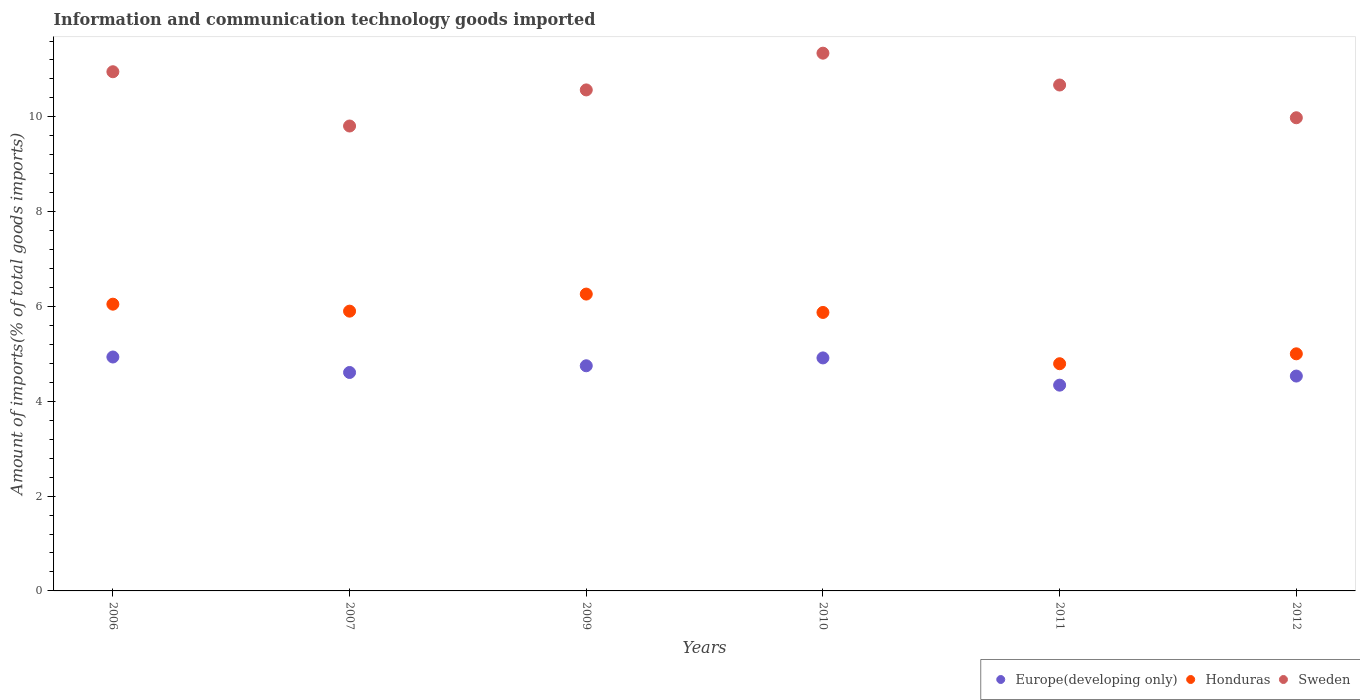How many different coloured dotlines are there?
Your answer should be compact. 3. Is the number of dotlines equal to the number of legend labels?
Your answer should be compact. Yes. What is the amount of goods imported in Sweden in 2009?
Provide a short and direct response. 10.57. Across all years, what is the maximum amount of goods imported in Honduras?
Your answer should be compact. 6.26. Across all years, what is the minimum amount of goods imported in Sweden?
Keep it short and to the point. 9.81. In which year was the amount of goods imported in Honduras minimum?
Offer a terse response. 2011. What is the total amount of goods imported in Sweden in the graph?
Your answer should be compact. 63.33. What is the difference between the amount of goods imported in Europe(developing only) in 2006 and that in 2012?
Your answer should be compact. 0.4. What is the difference between the amount of goods imported in Sweden in 2006 and the amount of goods imported in Honduras in 2010?
Provide a succinct answer. 5.08. What is the average amount of goods imported in Sweden per year?
Ensure brevity in your answer.  10.55. In the year 2006, what is the difference between the amount of goods imported in Honduras and amount of goods imported in Sweden?
Ensure brevity in your answer.  -4.9. In how many years, is the amount of goods imported in Europe(developing only) greater than 6.4 %?
Provide a short and direct response. 0. What is the ratio of the amount of goods imported in Sweden in 2007 to that in 2012?
Provide a short and direct response. 0.98. Is the amount of goods imported in Europe(developing only) in 2009 less than that in 2010?
Keep it short and to the point. Yes. Is the difference between the amount of goods imported in Honduras in 2006 and 2011 greater than the difference between the amount of goods imported in Sweden in 2006 and 2011?
Your answer should be very brief. Yes. What is the difference between the highest and the second highest amount of goods imported in Honduras?
Your answer should be very brief. 0.21. What is the difference between the highest and the lowest amount of goods imported in Sweden?
Offer a very short reply. 1.54. In how many years, is the amount of goods imported in Europe(developing only) greater than the average amount of goods imported in Europe(developing only) taken over all years?
Provide a succinct answer. 3. Is the sum of the amount of goods imported in Sweden in 2006 and 2009 greater than the maximum amount of goods imported in Europe(developing only) across all years?
Your answer should be compact. Yes. Is it the case that in every year, the sum of the amount of goods imported in Honduras and amount of goods imported in Sweden  is greater than the amount of goods imported in Europe(developing only)?
Offer a very short reply. Yes. Is the amount of goods imported in Europe(developing only) strictly less than the amount of goods imported in Honduras over the years?
Provide a short and direct response. Yes. How many dotlines are there?
Your response must be concise. 3. How many years are there in the graph?
Offer a very short reply. 6. Are the values on the major ticks of Y-axis written in scientific E-notation?
Keep it short and to the point. No. Where does the legend appear in the graph?
Your response must be concise. Bottom right. How are the legend labels stacked?
Keep it short and to the point. Horizontal. What is the title of the graph?
Make the answer very short. Information and communication technology goods imported. What is the label or title of the Y-axis?
Your response must be concise. Amount of imports(% of total goods imports). What is the Amount of imports(% of total goods imports) of Europe(developing only) in 2006?
Your answer should be compact. 4.93. What is the Amount of imports(% of total goods imports) in Honduras in 2006?
Ensure brevity in your answer.  6.05. What is the Amount of imports(% of total goods imports) of Sweden in 2006?
Ensure brevity in your answer.  10.95. What is the Amount of imports(% of total goods imports) of Europe(developing only) in 2007?
Give a very brief answer. 4.61. What is the Amount of imports(% of total goods imports) in Honduras in 2007?
Provide a succinct answer. 5.9. What is the Amount of imports(% of total goods imports) in Sweden in 2007?
Give a very brief answer. 9.81. What is the Amount of imports(% of total goods imports) in Europe(developing only) in 2009?
Your response must be concise. 4.75. What is the Amount of imports(% of total goods imports) in Honduras in 2009?
Your answer should be compact. 6.26. What is the Amount of imports(% of total goods imports) of Sweden in 2009?
Provide a succinct answer. 10.57. What is the Amount of imports(% of total goods imports) of Europe(developing only) in 2010?
Offer a terse response. 4.92. What is the Amount of imports(% of total goods imports) of Honduras in 2010?
Your answer should be very brief. 5.87. What is the Amount of imports(% of total goods imports) of Sweden in 2010?
Offer a terse response. 11.34. What is the Amount of imports(% of total goods imports) of Europe(developing only) in 2011?
Provide a succinct answer. 4.34. What is the Amount of imports(% of total goods imports) of Honduras in 2011?
Ensure brevity in your answer.  4.79. What is the Amount of imports(% of total goods imports) of Sweden in 2011?
Give a very brief answer. 10.67. What is the Amount of imports(% of total goods imports) of Europe(developing only) in 2012?
Your answer should be very brief. 4.53. What is the Amount of imports(% of total goods imports) in Honduras in 2012?
Offer a terse response. 5. What is the Amount of imports(% of total goods imports) in Sweden in 2012?
Your answer should be compact. 9.98. Across all years, what is the maximum Amount of imports(% of total goods imports) in Europe(developing only)?
Your answer should be compact. 4.93. Across all years, what is the maximum Amount of imports(% of total goods imports) in Honduras?
Your answer should be compact. 6.26. Across all years, what is the maximum Amount of imports(% of total goods imports) of Sweden?
Make the answer very short. 11.34. Across all years, what is the minimum Amount of imports(% of total goods imports) in Europe(developing only)?
Your answer should be compact. 4.34. Across all years, what is the minimum Amount of imports(% of total goods imports) of Honduras?
Provide a short and direct response. 4.79. Across all years, what is the minimum Amount of imports(% of total goods imports) of Sweden?
Provide a short and direct response. 9.81. What is the total Amount of imports(% of total goods imports) of Europe(developing only) in the graph?
Offer a very short reply. 28.08. What is the total Amount of imports(% of total goods imports) of Honduras in the graph?
Ensure brevity in your answer.  33.88. What is the total Amount of imports(% of total goods imports) in Sweden in the graph?
Provide a succinct answer. 63.33. What is the difference between the Amount of imports(% of total goods imports) of Europe(developing only) in 2006 and that in 2007?
Offer a terse response. 0.33. What is the difference between the Amount of imports(% of total goods imports) in Honduras in 2006 and that in 2007?
Provide a short and direct response. 0.15. What is the difference between the Amount of imports(% of total goods imports) of Sweden in 2006 and that in 2007?
Provide a short and direct response. 1.14. What is the difference between the Amount of imports(% of total goods imports) in Europe(developing only) in 2006 and that in 2009?
Your answer should be very brief. 0.19. What is the difference between the Amount of imports(% of total goods imports) of Honduras in 2006 and that in 2009?
Your response must be concise. -0.21. What is the difference between the Amount of imports(% of total goods imports) in Sweden in 2006 and that in 2009?
Give a very brief answer. 0.38. What is the difference between the Amount of imports(% of total goods imports) in Europe(developing only) in 2006 and that in 2010?
Provide a short and direct response. 0.02. What is the difference between the Amount of imports(% of total goods imports) of Honduras in 2006 and that in 2010?
Your answer should be very brief. 0.17. What is the difference between the Amount of imports(% of total goods imports) in Sweden in 2006 and that in 2010?
Offer a very short reply. -0.39. What is the difference between the Amount of imports(% of total goods imports) of Europe(developing only) in 2006 and that in 2011?
Your answer should be compact. 0.59. What is the difference between the Amount of imports(% of total goods imports) in Honduras in 2006 and that in 2011?
Give a very brief answer. 1.26. What is the difference between the Amount of imports(% of total goods imports) of Sweden in 2006 and that in 2011?
Ensure brevity in your answer.  0.28. What is the difference between the Amount of imports(% of total goods imports) of Europe(developing only) in 2006 and that in 2012?
Offer a terse response. 0.4. What is the difference between the Amount of imports(% of total goods imports) of Honduras in 2006 and that in 2012?
Your answer should be very brief. 1.05. What is the difference between the Amount of imports(% of total goods imports) of Sweden in 2006 and that in 2012?
Keep it short and to the point. 0.97. What is the difference between the Amount of imports(% of total goods imports) in Europe(developing only) in 2007 and that in 2009?
Offer a terse response. -0.14. What is the difference between the Amount of imports(% of total goods imports) of Honduras in 2007 and that in 2009?
Give a very brief answer. -0.36. What is the difference between the Amount of imports(% of total goods imports) in Sweden in 2007 and that in 2009?
Your response must be concise. -0.76. What is the difference between the Amount of imports(% of total goods imports) of Europe(developing only) in 2007 and that in 2010?
Ensure brevity in your answer.  -0.31. What is the difference between the Amount of imports(% of total goods imports) in Honduras in 2007 and that in 2010?
Offer a terse response. 0.03. What is the difference between the Amount of imports(% of total goods imports) of Sweden in 2007 and that in 2010?
Keep it short and to the point. -1.54. What is the difference between the Amount of imports(% of total goods imports) in Europe(developing only) in 2007 and that in 2011?
Provide a short and direct response. 0.27. What is the difference between the Amount of imports(% of total goods imports) of Honduras in 2007 and that in 2011?
Ensure brevity in your answer.  1.11. What is the difference between the Amount of imports(% of total goods imports) in Sweden in 2007 and that in 2011?
Offer a very short reply. -0.86. What is the difference between the Amount of imports(% of total goods imports) in Europe(developing only) in 2007 and that in 2012?
Your answer should be very brief. 0.08. What is the difference between the Amount of imports(% of total goods imports) in Honduras in 2007 and that in 2012?
Your answer should be compact. 0.9. What is the difference between the Amount of imports(% of total goods imports) in Sweden in 2007 and that in 2012?
Make the answer very short. -0.17. What is the difference between the Amount of imports(% of total goods imports) in Europe(developing only) in 2009 and that in 2010?
Keep it short and to the point. -0.17. What is the difference between the Amount of imports(% of total goods imports) of Honduras in 2009 and that in 2010?
Keep it short and to the point. 0.39. What is the difference between the Amount of imports(% of total goods imports) of Sweden in 2009 and that in 2010?
Provide a short and direct response. -0.78. What is the difference between the Amount of imports(% of total goods imports) in Europe(developing only) in 2009 and that in 2011?
Keep it short and to the point. 0.41. What is the difference between the Amount of imports(% of total goods imports) in Honduras in 2009 and that in 2011?
Keep it short and to the point. 1.47. What is the difference between the Amount of imports(% of total goods imports) of Sweden in 2009 and that in 2011?
Offer a terse response. -0.1. What is the difference between the Amount of imports(% of total goods imports) of Europe(developing only) in 2009 and that in 2012?
Make the answer very short. 0.22. What is the difference between the Amount of imports(% of total goods imports) of Honduras in 2009 and that in 2012?
Give a very brief answer. 1.26. What is the difference between the Amount of imports(% of total goods imports) in Sweden in 2009 and that in 2012?
Keep it short and to the point. 0.59. What is the difference between the Amount of imports(% of total goods imports) of Europe(developing only) in 2010 and that in 2011?
Provide a succinct answer. 0.57. What is the difference between the Amount of imports(% of total goods imports) in Honduras in 2010 and that in 2011?
Your answer should be very brief. 1.08. What is the difference between the Amount of imports(% of total goods imports) of Sweden in 2010 and that in 2011?
Provide a short and direct response. 0.67. What is the difference between the Amount of imports(% of total goods imports) of Europe(developing only) in 2010 and that in 2012?
Offer a very short reply. 0.38. What is the difference between the Amount of imports(% of total goods imports) in Honduras in 2010 and that in 2012?
Your response must be concise. 0.87. What is the difference between the Amount of imports(% of total goods imports) in Sweden in 2010 and that in 2012?
Provide a succinct answer. 1.36. What is the difference between the Amount of imports(% of total goods imports) in Europe(developing only) in 2011 and that in 2012?
Offer a very short reply. -0.19. What is the difference between the Amount of imports(% of total goods imports) of Honduras in 2011 and that in 2012?
Make the answer very short. -0.21. What is the difference between the Amount of imports(% of total goods imports) in Sweden in 2011 and that in 2012?
Give a very brief answer. 0.69. What is the difference between the Amount of imports(% of total goods imports) of Europe(developing only) in 2006 and the Amount of imports(% of total goods imports) of Honduras in 2007?
Your answer should be compact. -0.97. What is the difference between the Amount of imports(% of total goods imports) in Europe(developing only) in 2006 and the Amount of imports(% of total goods imports) in Sweden in 2007?
Keep it short and to the point. -4.87. What is the difference between the Amount of imports(% of total goods imports) of Honduras in 2006 and the Amount of imports(% of total goods imports) of Sweden in 2007?
Your answer should be very brief. -3.76. What is the difference between the Amount of imports(% of total goods imports) of Europe(developing only) in 2006 and the Amount of imports(% of total goods imports) of Honduras in 2009?
Provide a short and direct response. -1.33. What is the difference between the Amount of imports(% of total goods imports) in Europe(developing only) in 2006 and the Amount of imports(% of total goods imports) in Sweden in 2009?
Ensure brevity in your answer.  -5.63. What is the difference between the Amount of imports(% of total goods imports) of Honduras in 2006 and the Amount of imports(% of total goods imports) of Sweden in 2009?
Your response must be concise. -4.52. What is the difference between the Amount of imports(% of total goods imports) in Europe(developing only) in 2006 and the Amount of imports(% of total goods imports) in Honduras in 2010?
Give a very brief answer. -0.94. What is the difference between the Amount of imports(% of total goods imports) in Europe(developing only) in 2006 and the Amount of imports(% of total goods imports) in Sweden in 2010?
Provide a succinct answer. -6.41. What is the difference between the Amount of imports(% of total goods imports) in Honduras in 2006 and the Amount of imports(% of total goods imports) in Sweden in 2010?
Make the answer very short. -5.29. What is the difference between the Amount of imports(% of total goods imports) of Europe(developing only) in 2006 and the Amount of imports(% of total goods imports) of Honduras in 2011?
Your response must be concise. 0.14. What is the difference between the Amount of imports(% of total goods imports) in Europe(developing only) in 2006 and the Amount of imports(% of total goods imports) in Sweden in 2011?
Ensure brevity in your answer.  -5.74. What is the difference between the Amount of imports(% of total goods imports) in Honduras in 2006 and the Amount of imports(% of total goods imports) in Sweden in 2011?
Your answer should be compact. -4.62. What is the difference between the Amount of imports(% of total goods imports) of Europe(developing only) in 2006 and the Amount of imports(% of total goods imports) of Honduras in 2012?
Provide a short and direct response. -0.07. What is the difference between the Amount of imports(% of total goods imports) of Europe(developing only) in 2006 and the Amount of imports(% of total goods imports) of Sweden in 2012?
Give a very brief answer. -5.05. What is the difference between the Amount of imports(% of total goods imports) in Honduras in 2006 and the Amount of imports(% of total goods imports) in Sweden in 2012?
Give a very brief answer. -3.93. What is the difference between the Amount of imports(% of total goods imports) of Europe(developing only) in 2007 and the Amount of imports(% of total goods imports) of Honduras in 2009?
Provide a succinct answer. -1.65. What is the difference between the Amount of imports(% of total goods imports) in Europe(developing only) in 2007 and the Amount of imports(% of total goods imports) in Sweden in 2009?
Offer a terse response. -5.96. What is the difference between the Amount of imports(% of total goods imports) of Honduras in 2007 and the Amount of imports(% of total goods imports) of Sweden in 2009?
Offer a very short reply. -4.67. What is the difference between the Amount of imports(% of total goods imports) of Europe(developing only) in 2007 and the Amount of imports(% of total goods imports) of Honduras in 2010?
Provide a succinct answer. -1.27. What is the difference between the Amount of imports(% of total goods imports) in Europe(developing only) in 2007 and the Amount of imports(% of total goods imports) in Sweden in 2010?
Provide a short and direct response. -6.74. What is the difference between the Amount of imports(% of total goods imports) of Honduras in 2007 and the Amount of imports(% of total goods imports) of Sweden in 2010?
Your answer should be compact. -5.44. What is the difference between the Amount of imports(% of total goods imports) in Europe(developing only) in 2007 and the Amount of imports(% of total goods imports) in Honduras in 2011?
Ensure brevity in your answer.  -0.18. What is the difference between the Amount of imports(% of total goods imports) of Europe(developing only) in 2007 and the Amount of imports(% of total goods imports) of Sweden in 2011?
Your response must be concise. -6.06. What is the difference between the Amount of imports(% of total goods imports) of Honduras in 2007 and the Amount of imports(% of total goods imports) of Sweden in 2011?
Your answer should be compact. -4.77. What is the difference between the Amount of imports(% of total goods imports) in Europe(developing only) in 2007 and the Amount of imports(% of total goods imports) in Honduras in 2012?
Make the answer very short. -0.39. What is the difference between the Amount of imports(% of total goods imports) in Europe(developing only) in 2007 and the Amount of imports(% of total goods imports) in Sweden in 2012?
Your answer should be very brief. -5.37. What is the difference between the Amount of imports(% of total goods imports) of Honduras in 2007 and the Amount of imports(% of total goods imports) of Sweden in 2012?
Give a very brief answer. -4.08. What is the difference between the Amount of imports(% of total goods imports) of Europe(developing only) in 2009 and the Amount of imports(% of total goods imports) of Honduras in 2010?
Provide a short and direct response. -1.12. What is the difference between the Amount of imports(% of total goods imports) of Europe(developing only) in 2009 and the Amount of imports(% of total goods imports) of Sweden in 2010?
Give a very brief answer. -6.59. What is the difference between the Amount of imports(% of total goods imports) in Honduras in 2009 and the Amount of imports(% of total goods imports) in Sweden in 2010?
Keep it short and to the point. -5.08. What is the difference between the Amount of imports(% of total goods imports) in Europe(developing only) in 2009 and the Amount of imports(% of total goods imports) in Honduras in 2011?
Your response must be concise. -0.04. What is the difference between the Amount of imports(% of total goods imports) in Europe(developing only) in 2009 and the Amount of imports(% of total goods imports) in Sweden in 2011?
Provide a short and direct response. -5.92. What is the difference between the Amount of imports(% of total goods imports) of Honduras in 2009 and the Amount of imports(% of total goods imports) of Sweden in 2011?
Ensure brevity in your answer.  -4.41. What is the difference between the Amount of imports(% of total goods imports) in Europe(developing only) in 2009 and the Amount of imports(% of total goods imports) in Honduras in 2012?
Offer a terse response. -0.25. What is the difference between the Amount of imports(% of total goods imports) in Europe(developing only) in 2009 and the Amount of imports(% of total goods imports) in Sweden in 2012?
Your answer should be compact. -5.23. What is the difference between the Amount of imports(% of total goods imports) in Honduras in 2009 and the Amount of imports(% of total goods imports) in Sweden in 2012?
Your response must be concise. -3.72. What is the difference between the Amount of imports(% of total goods imports) of Europe(developing only) in 2010 and the Amount of imports(% of total goods imports) of Honduras in 2011?
Provide a succinct answer. 0.12. What is the difference between the Amount of imports(% of total goods imports) in Europe(developing only) in 2010 and the Amount of imports(% of total goods imports) in Sweden in 2011?
Provide a short and direct response. -5.76. What is the difference between the Amount of imports(% of total goods imports) in Honduras in 2010 and the Amount of imports(% of total goods imports) in Sweden in 2011?
Your response must be concise. -4.8. What is the difference between the Amount of imports(% of total goods imports) in Europe(developing only) in 2010 and the Amount of imports(% of total goods imports) in Honduras in 2012?
Keep it short and to the point. -0.09. What is the difference between the Amount of imports(% of total goods imports) of Europe(developing only) in 2010 and the Amount of imports(% of total goods imports) of Sweden in 2012?
Ensure brevity in your answer.  -5.07. What is the difference between the Amount of imports(% of total goods imports) of Honduras in 2010 and the Amount of imports(% of total goods imports) of Sweden in 2012?
Offer a terse response. -4.11. What is the difference between the Amount of imports(% of total goods imports) in Europe(developing only) in 2011 and the Amount of imports(% of total goods imports) in Honduras in 2012?
Provide a short and direct response. -0.66. What is the difference between the Amount of imports(% of total goods imports) in Europe(developing only) in 2011 and the Amount of imports(% of total goods imports) in Sweden in 2012?
Provide a short and direct response. -5.64. What is the difference between the Amount of imports(% of total goods imports) in Honduras in 2011 and the Amount of imports(% of total goods imports) in Sweden in 2012?
Provide a succinct answer. -5.19. What is the average Amount of imports(% of total goods imports) in Europe(developing only) per year?
Make the answer very short. 4.68. What is the average Amount of imports(% of total goods imports) in Honduras per year?
Ensure brevity in your answer.  5.65. What is the average Amount of imports(% of total goods imports) in Sweden per year?
Your response must be concise. 10.55. In the year 2006, what is the difference between the Amount of imports(% of total goods imports) of Europe(developing only) and Amount of imports(% of total goods imports) of Honduras?
Make the answer very short. -1.11. In the year 2006, what is the difference between the Amount of imports(% of total goods imports) in Europe(developing only) and Amount of imports(% of total goods imports) in Sweden?
Your answer should be compact. -6.02. In the year 2006, what is the difference between the Amount of imports(% of total goods imports) of Honduras and Amount of imports(% of total goods imports) of Sweden?
Offer a terse response. -4.9. In the year 2007, what is the difference between the Amount of imports(% of total goods imports) in Europe(developing only) and Amount of imports(% of total goods imports) in Honduras?
Provide a short and direct response. -1.29. In the year 2007, what is the difference between the Amount of imports(% of total goods imports) in Europe(developing only) and Amount of imports(% of total goods imports) in Sweden?
Offer a very short reply. -5.2. In the year 2007, what is the difference between the Amount of imports(% of total goods imports) of Honduras and Amount of imports(% of total goods imports) of Sweden?
Offer a very short reply. -3.91. In the year 2009, what is the difference between the Amount of imports(% of total goods imports) in Europe(developing only) and Amount of imports(% of total goods imports) in Honduras?
Provide a succinct answer. -1.51. In the year 2009, what is the difference between the Amount of imports(% of total goods imports) of Europe(developing only) and Amount of imports(% of total goods imports) of Sweden?
Your response must be concise. -5.82. In the year 2009, what is the difference between the Amount of imports(% of total goods imports) of Honduras and Amount of imports(% of total goods imports) of Sweden?
Provide a succinct answer. -4.31. In the year 2010, what is the difference between the Amount of imports(% of total goods imports) of Europe(developing only) and Amount of imports(% of total goods imports) of Honduras?
Keep it short and to the point. -0.96. In the year 2010, what is the difference between the Amount of imports(% of total goods imports) in Europe(developing only) and Amount of imports(% of total goods imports) in Sweden?
Ensure brevity in your answer.  -6.43. In the year 2010, what is the difference between the Amount of imports(% of total goods imports) in Honduras and Amount of imports(% of total goods imports) in Sweden?
Give a very brief answer. -5.47. In the year 2011, what is the difference between the Amount of imports(% of total goods imports) in Europe(developing only) and Amount of imports(% of total goods imports) in Honduras?
Your answer should be very brief. -0.45. In the year 2011, what is the difference between the Amount of imports(% of total goods imports) in Europe(developing only) and Amount of imports(% of total goods imports) in Sweden?
Offer a terse response. -6.33. In the year 2011, what is the difference between the Amount of imports(% of total goods imports) of Honduras and Amount of imports(% of total goods imports) of Sweden?
Your response must be concise. -5.88. In the year 2012, what is the difference between the Amount of imports(% of total goods imports) in Europe(developing only) and Amount of imports(% of total goods imports) in Honduras?
Your answer should be compact. -0.47. In the year 2012, what is the difference between the Amount of imports(% of total goods imports) in Europe(developing only) and Amount of imports(% of total goods imports) in Sweden?
Your response must be concise. -5.45. In the year 2012, what is the difference between the Amount of imports(% of total goods imports) in Honduras and Amount of imports(% of total goods imports) in Sweden?
Your response must be concise. -4.98. What is the ratio of the Amount of imports(% of total goods imports) in Europe(developing only) in 2006 to that in 2007?
Your answer should be very brief. 1.07. What is the ratio of the Amount of imports(% of total goods imports) of Honduras in 2006 to that in 2007?
Provide a short and direct response. 1.02. What is the ratio of the Amount of imports(% of total goods imports) in Sweden in 2006 to that in 2007?
Give a very brief answer. 1.12. What is the ratio of the Amount of imports(% of total goods imports) of Europe(developing only) in 2006 to that in 2009?
Ensure brevity in your answer.  1.04. What is the ratio of the Amount of imports(% of total goods imports) of Honduras in 2006 to that in 2009?
Provide a succinct answer. 0.97. What is the ratio of the Amount of imports(% of total goods imports) of Sweden in 2006 to that in 2009?
Ensure brevity in your answer.  1.04. What is the ratio of the Amount of imports(% of total goods imports) of Europe(developing only) in 2006 to that in 2010?
Provide a short and direct response. 1. What is the ratio of the Amount of imports(% of total goods imports) in Honduras in 2006 to that in 2010?
Your answer should be very brief. 1.03. What is the ratio of the Amount of imports(% of total goods imports) in Sweden in 2006 to that in 2010?
Offer a terse response. 0.97. What is the ratio of the Amount of imports(% of total goods imports) of Europe(developing only) in 2006 to that in 2011?
Provide a short and direct response. 1.14. What is the ratio of the Amount of imports(% of total goods imports) in Honduras in 2006 to that in 2011?
Give a very brief answer. 1.26. What is the ratio of the Amount of imports(% of total goods imports) in Sweden in 2006 to that in 2011?
Make the answer very short. 1.03. What is the ratio of the Amount of imports(% of total goods imports) in Europe(developing only) in 2006 to that in 2012?
Offer a terse response. 1.09. What is the ratio of the Amount of imports(% of total goods imports) in Honduras in 2006 to that in 2012?
Ensure brevity in your answer.  1.21. What is the ratio of the Amount of imports(% of total goods imports) of Sweden in 2006 to that in 2012?
Offer a terse response. 1.1. What is the ratio of the Amount of imports(% of total goods imports) of Europe(developing only) in 2007 to that in 2009?
Offer a very short reply. 0.97. What is the ratio of the Amount of imports(% of total goods imports) of Honduras in 2007 to that in 2009?
Make the answer very short. 0.94. What is the ratio of the Amount of imports(% of total goods imports) of Sweden in 2007 to that in 2009?
Keep it short and to the point. 0.93. What is the ratio of the Amount of imports(% of total goods imports) of Europe(developing only) in 2007 to that in 2010?
Make the answer very short. 0.94. What is the ratio of the Amount of imports(% of total goods imports) of Sweden in 2007 to that in 2010?
Provide a succinct answer. 0.86. What is the ratio of the Amount of imports(% of total goods imports) of Europe(developing only) in 2007 to that in 2011?
Your answer should be very brief. 1.06. What is the ratio of the Amount of imports(% of total goods imports) in Honduras in 2007 to that in 2011?
Your response must be concise. 1.23. What is the ratio of the Amount of imports(% of total goods imports) in Sweden in 2007 to that in 2011?
Your response must be concise. 0.92. What is the ratio of the Amount of imports(% of total goods imports) of Europe(developing only) in 2007 to that in 2012?
Your response must be concise. 1.02. What is the ratio of the Amount of imports(% of total goods imports) in Honduras in 2007 to that in 2012?
Your response must be concise. 1.18. What is the ratio of the Amount of imports(% of total goods imports) in Sweden in 2007 to that in 2012?
Ensure brevity in your answer.  0.98. What is the ratio of the Amount of imports(% of total goods imports) of Europe(developing only) in 2009 to that in 2010?
Provide a short and direct response. 0.97. What is the ratio of the Amount of imports(% of total goods imports) in Honduras in 2009 to that in 2010?
Offer a terse response. 1.07. What is the ratio of the Amount of imports(% of total goods imports) in Sweden in 2009 to that in 2010?
Offer a terse response. 0.93. What is the ratio of the Amount of imports(% of total goods imports) of Europe(developing only) in 2009 to that in 2011?
Keep it short and to the point. 1.09. What is the ratio of the Amount of imports(% of total goods imports) in Honduras in 2009 to that in 2011?
Give a very brief answer. 1.31. What is the ratio of the Amount of imports(% of total goods imports) of Sweden in 2009 to that in 2011?
Make the answer very short. 0.99. What is the ratio of the Amount of imports(% of total goods imports) in Europe(developing only) in 2009 to that in 2012?
Make the answer very short. 1.05. What is the ratio of the Amount of imports(% of total goods imports) in Honduras in 2009 to that in 2012?
Your answer should be very brief. 1.25. What is the ratio of the Amount of imports(% of total goods imports) of Sweden in 2009 to that in 2012?
Keep it short and to the point. 1.06. What is the ratio of the Amount of imports(% of total goods imports) in Europe(developing only) in 2010 to that in 2011?
Give a very brief answer. 1.13. What is the ratio of the Amount of imports(% of total goods imports) in Honduras in 2010 to that in 2011?
Ensure brevity in your answer.  1.23. What is the ratio of the Amount of imports(% of total goods imports) of Sweden in 2010 to that in 2011?
Provide a short and direct response. 1.06. What is the ratio of the Amount of imports(% of total goods imports) in Europe(developing only) in 2010 to that in 2012?
Give a very brief answer. 1.08. What is the ratio of the Amount of imports(% of total goods imports) of Honduras in 2010 to that in 2012?
Make the answer very short. 1.17. What is the ratio of the Amount of imports(% of total goods imports) of Sweden in 2010 to that in 2012?
Give a very brief answer. 1.14. What is the ratio of the Amount of imports(% of total goods imports) in Europe(developing only) in 2011 to that in 2012?
Your answer should be very brief. 0.96. What is the ratio of the Amount of imports(% of total goods imports) in Honduras in 2011 to that in 2012?
Your answer should be compact. 0.96. What is the ratio of the Amount of imports(% of total goods imports) in Sweden in 2011 to that in 2012?
Provide a succinct answer. 1.07. What is the difference between the highest and the second highest Amount of imports(% of total goods imports) of Europe(developing only)?
Keep it short and to the point. 0.02. What is the difference between the highest and the second highest Amount of imports(% of total goods imports) of Honduras?
Provide a succinct answer. 0.21. What is the difference between the highest and the second highest Amount of imports(% of total goods imports) in Sweden?
Make the answer very short. 0.39. What is the difference between the highest and the lowest Amount of imports(% of total goods imports) in Europe(developing only)?
Offer a very short reply. 0.59. What is the difference between the highest and the lowest Amount of imports(% of total goods imports) in Honduras?
Your answer should be compact. 1.47. What is the difference between the highest and the lowest Amount of imports(% of total goods imports) in Sweden?
Give a very brief answer. 1.54. 